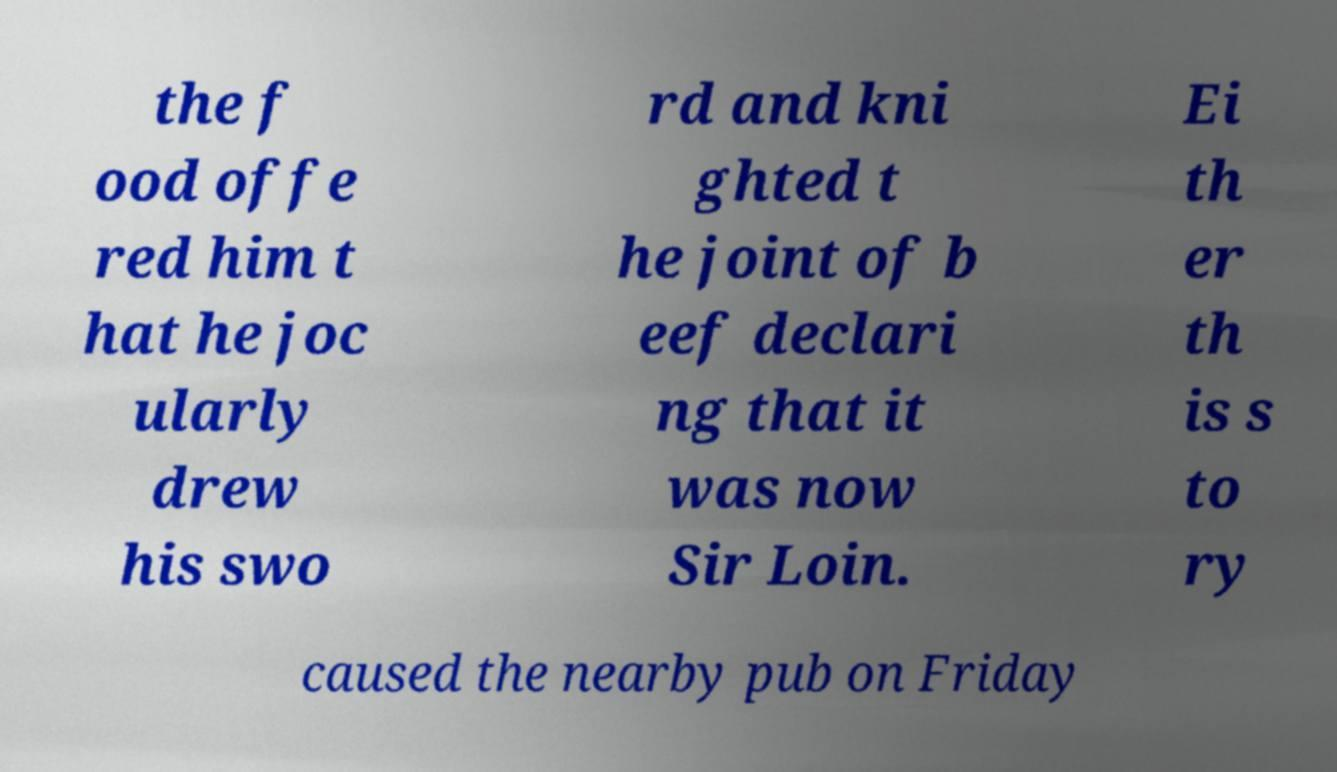I need the written content from this picture converted into text. Can you do that? the f ood offe red him t hat he joc ularly drew his swo rd and kni ghted t he joint of b eef declari ng that it was now Sir Loin. Ei th er th is s to ry caused the nearby pub on Friday 